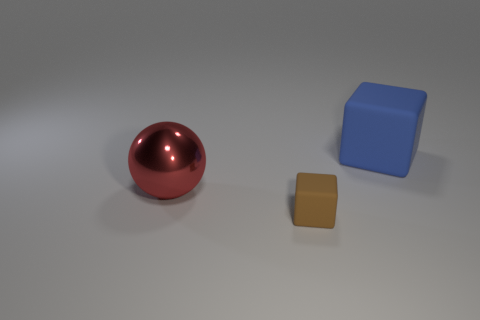Are there any other things that have the same size as the brown object?
Keep it short and to the point. No. Is there any other thing that has the same material as the tiny brown cube?
Your response must be concise. Yes. There is another object that is the same shape as the big blue rubber object; what is it made of?
Keep it short and to the point. Rubber. The big metallic ball is what color?
Your response must be concise. Red. What is the color of the matte object right of the rubber thing in front of the big block?
Provide a succinct answer. Blue. There is a large rubber thing; is its color the same as the matte block that is in front of the big red sphere?
Make the answer very short. No. How many rubber blocks are on the right side of the cube in front of the big thing that is left of the tiny brown cube?
Make the answer very short. 1. Are there any metal spheres behind the brown matte cube?
Your answer should be very brief. Yes. Are there any other things of the same color as the tiny block?
Give a very brief answer. No. What number of cylinders are matte things or big blue matte things?
Provide a succinct answer. 0. 